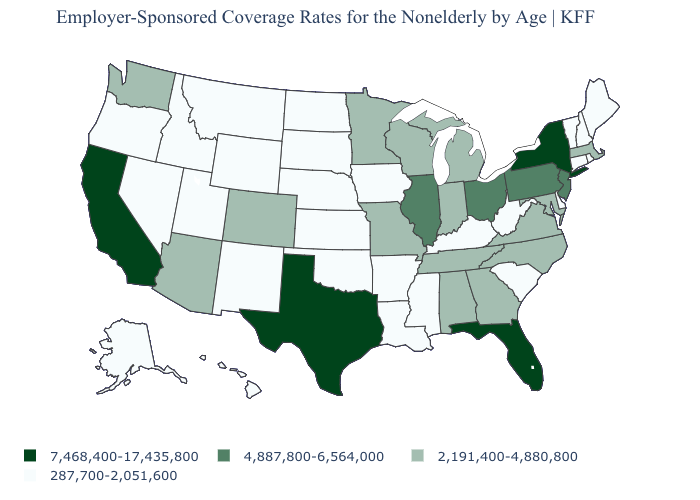Is the legend a continuous bar?
Concise answer only. No. What is the value of Ohio?
Answer briefly. 4,887,800-6,564,000. What is the lowest value in states that border Oregon?
Give a very brief answer. 287,700-2,051,600. What is the value of Delaware?
Quick response, please. 287,700-2,051,600. What is the value of New York?
Concise answer only. 7,468,400-17,435,800. What is the value of Iowa?
Be succinct. 287,700-2,051,600. Is the legend a continuous bar?
Answer briefly. No. What is the highest value in the South ?
Quick response, please. 7,468,400-17,435,800. What is the lowest value in the USA?
Quick response, please. 287,700-2,051,600. Name the states that have a value in the range 287,700-2,051,600?
Answer briefly. Alaska, Arkansas, Connecticut, Delaware, Hawaii, Idaho, Iowa, Kansas, Kentucky, Louisiana, Maine, Mississippi, Montana, Nebraska, Nevada, New Hampshire, New Mexico, North Dakota, Oklahoma, Oregon, Rhode Island, South Carolina, South Dakota, Utah, Vermont, West Virginia, Wyoming. Does the first symbol in the legend represent the smallest category?
Write a very short answer. No. Name the states that have a value in the range 287,700-2,051,600?
Short answer required. Alaska, Arkansas, Connecticut, Delaware, Hawaii, Idaho, Iowa, Kansas, Kentucky, Louisiana, Maine, Mississippi, Montana, Nebraska, Nevada, New Hampshire, New Mexico, North Dakota, Oklahoma, Oregon, Rhode Island, South Carolina, South Dakota, Utah, Vermont, West Virginia, Wyoming. What is the value of New Jersey?
Answer briefly. 4,887,800-6,564,000. Among the states that border California , which have the lowest value?
Write a very short answer. Nevada, Oregon. 